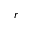Convert formula to latex. <formula><loc_0><loc_0><loc_500><loc_500>r</formula> 